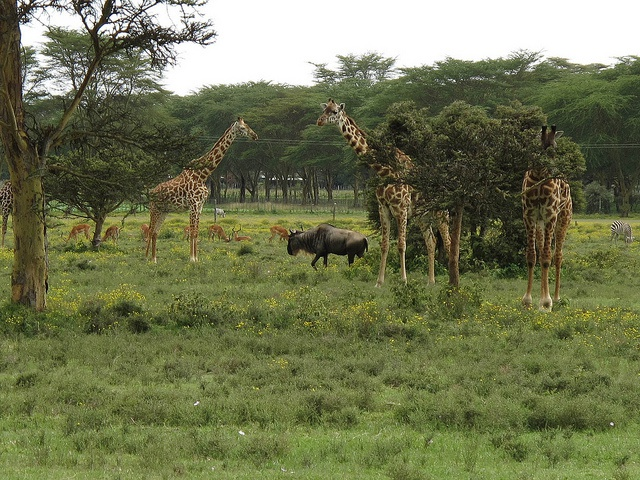Describe the objects in this image and their specific colors. I can see giraffe in black, darkgreen, olive, and tan tones, giraffe in black, olive, and tan tones, giraffe in black, olive, tan, and gray tones, and zebra in black, gray, olive, darkgreen, and darkgray tones in this image. 